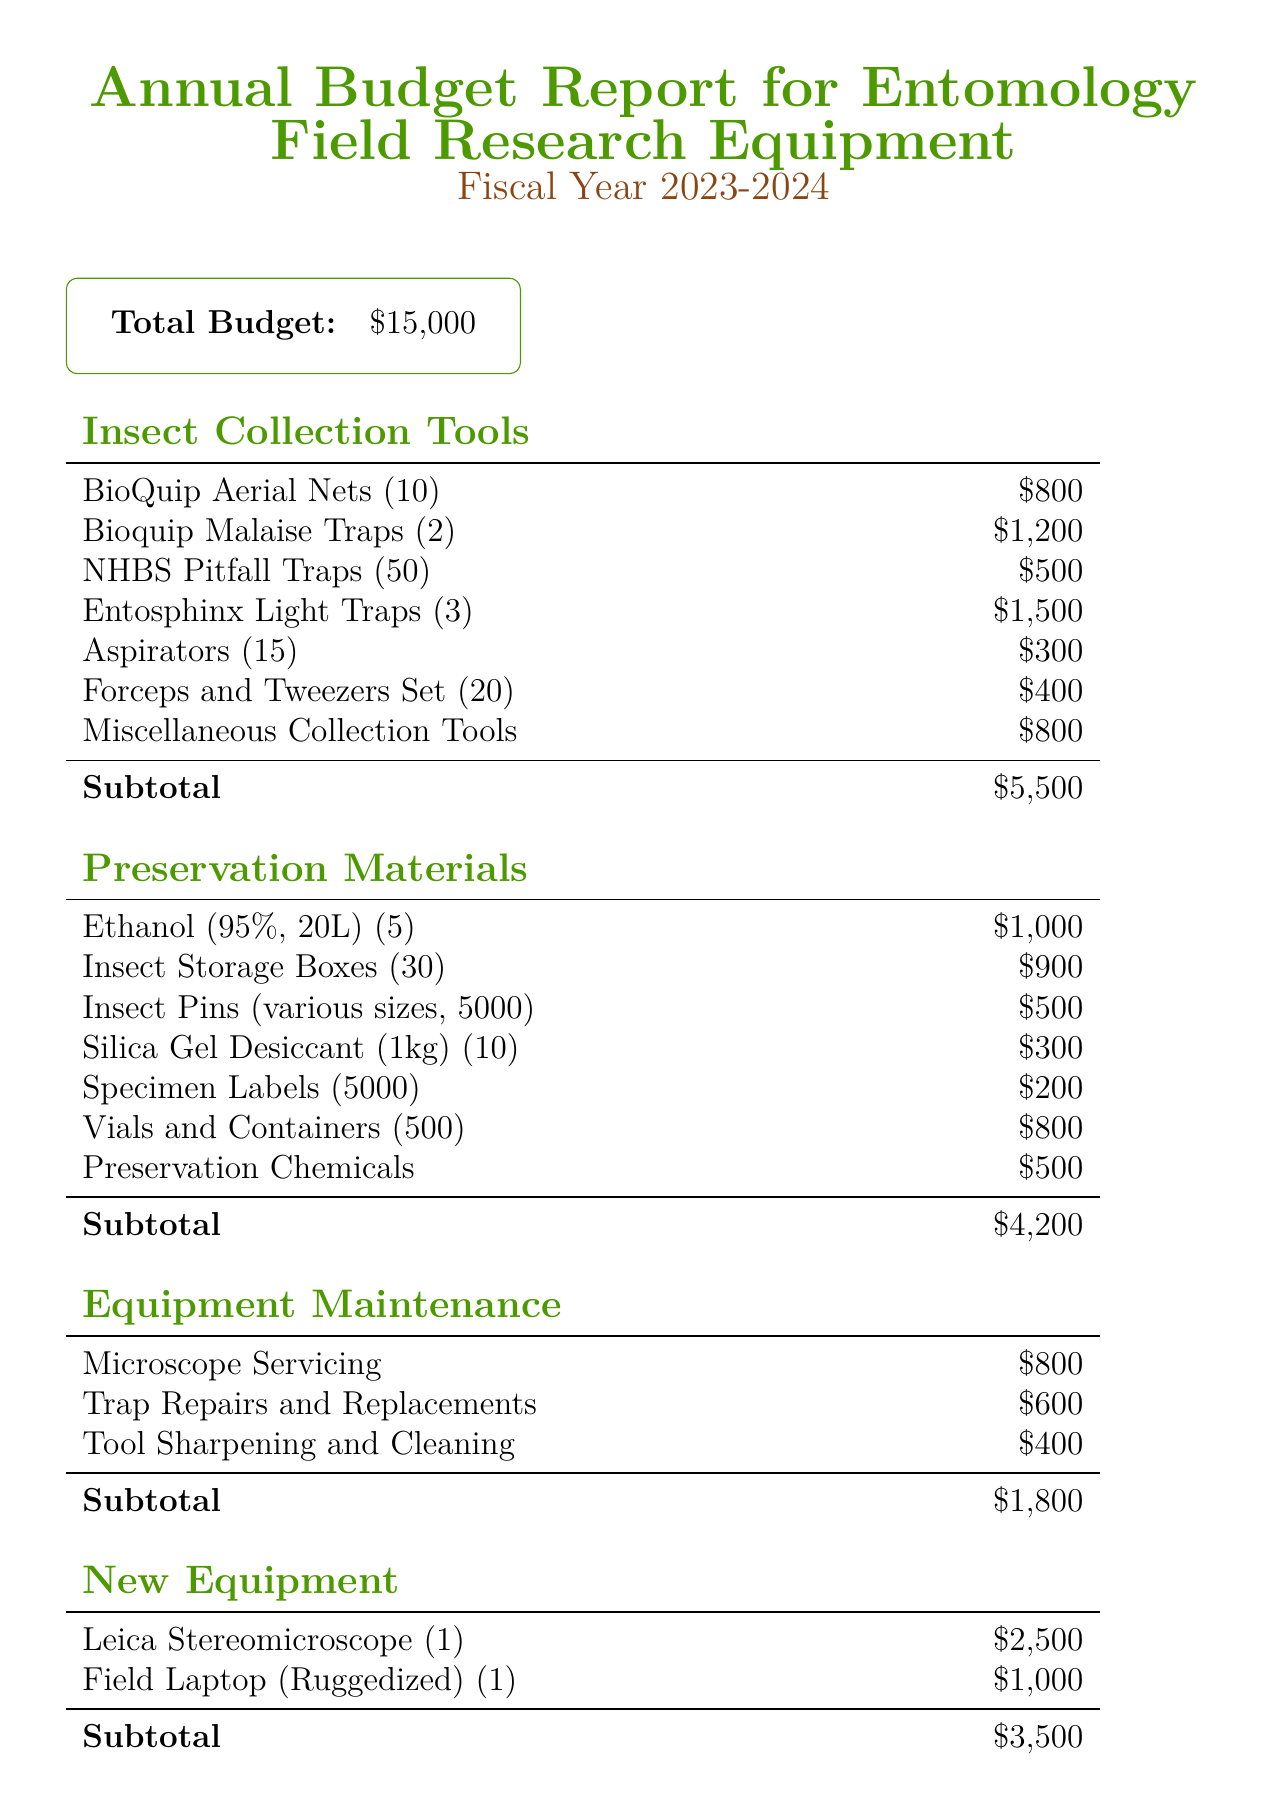what is the total budget? The total budget is specified as the overall amount allocated for the fiscal year, which is $15000.
Answer: $15000 how much is allocated for insect collection tools? The document provides a subtotal specifically for insect collection tools, which amounts to $5500.
Answer: $5500 which item costs $1500? The document lists Entosphinx Light Traps as the item that costs $1500 under insect collection tools.
Answer: Entosphinx Light Traps how many Ethanol containers are being purchased? The number of Ethanol containers mentioned in the preservation materials section is 5, indicating the quantity to be purchased.
Answer: 5 what percentage increase does this budget represent over the previous year? The document notes a budget increase of 10% from the previous year due to expanded Strobilaspis research.
Answer: 10% how much is allocated for new equipment? The total amount set aside for new equipment, according to the document, is $3500.
Answer: $3500 which maintenance item has the highest cost? The document indicates that the item with the highest cost under equipment maintenance is microscope servicing, which costs $800.
Answer: Microscope Servicing how many insect storage boxes are included in the budget? The document lists that 30 insect storage boxes are included in the preservation materials category.
Answer: 30 what specific priority is mentioned for the equipment purchased? The notes in the document emphasize durability, specifically mentioning "durable equipment suitable for tropical fieldwork conditions."
Answer: Durable equipment suitable for tropical fieldwork conditions 